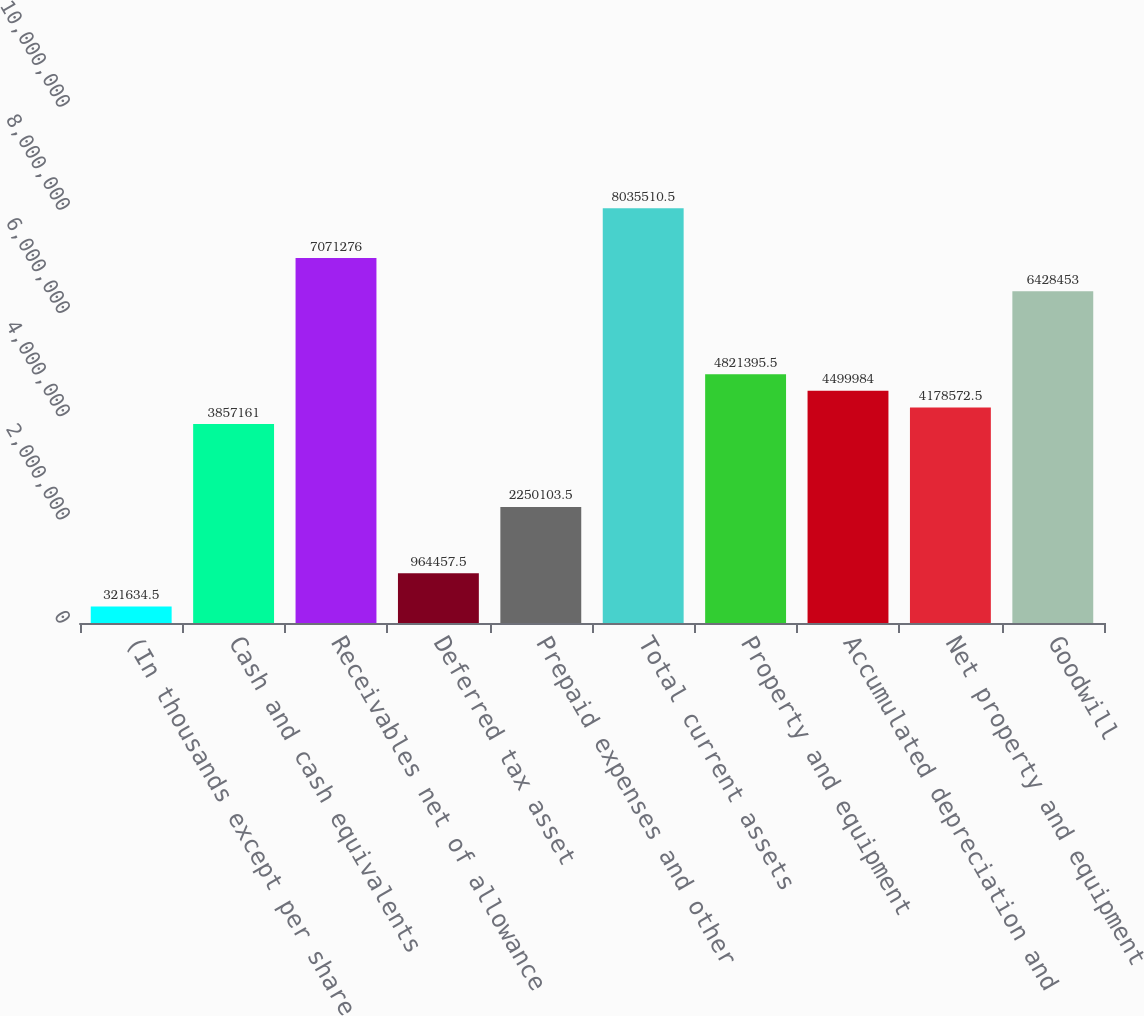Convert chart to OTSL. <chart><loc_0><loc_0><loc_500><loc_500><bar_chart><fcel>(In thousands except per share<fcel>Cash and cash equivalents<fcel>Receivables net of allowance<fcel>Deferred tax asset<fcel>Prepaid expenses and other<fcel>Total current assets<fcel>Property and equipment<fcel>Accumulated depreciation and<fcel>Net property and equipment<fcel>Goodwill<nl><fcel>321634<fcel>3.85716e+06<fcel>7.07128e+06<fcel>964458<fcel>2.2501e+06<fcel>8.03551e+06<fcel>4.8214e+06<fcel>4.49998e+06<fcel>4.17857e+06<fcel>6.42845e+06<nl></chart> 